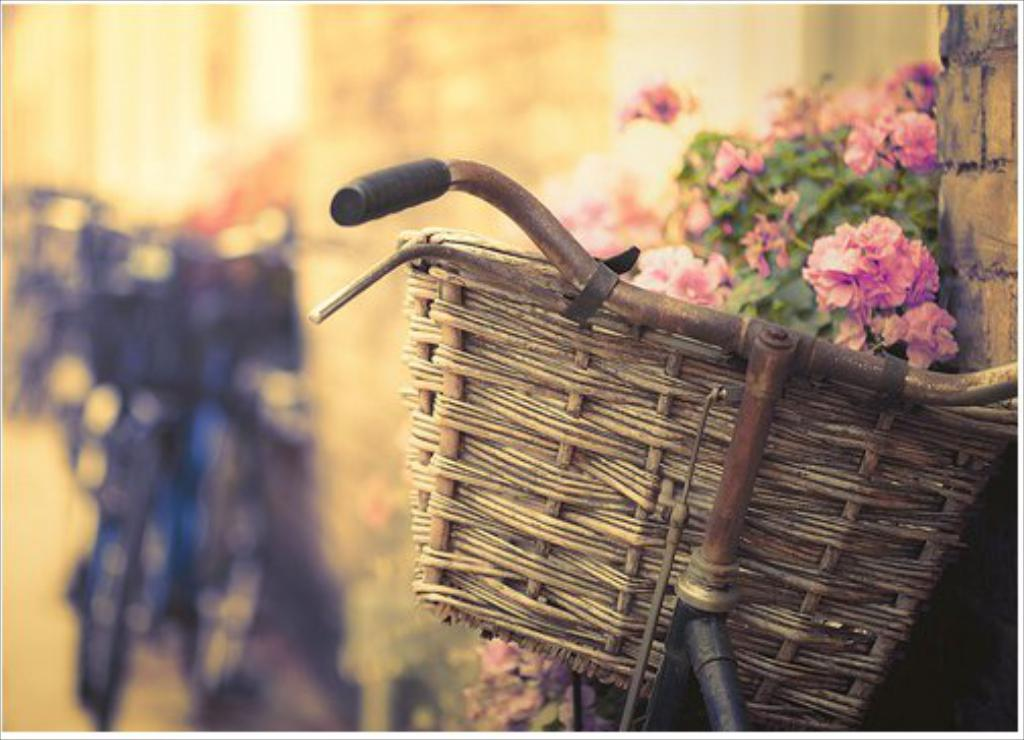What is in the basket that is visible in the image? There are flowers in a basket in the image. How is the basket connected to the cycle? The basket is attached to a cycle in the image. What can be observed about the background of the image? The background of the image is blurred. What type of meal is being prepared by the geese in the image? There are no geese present in the image, and therefore no meal preparation can be observed. 